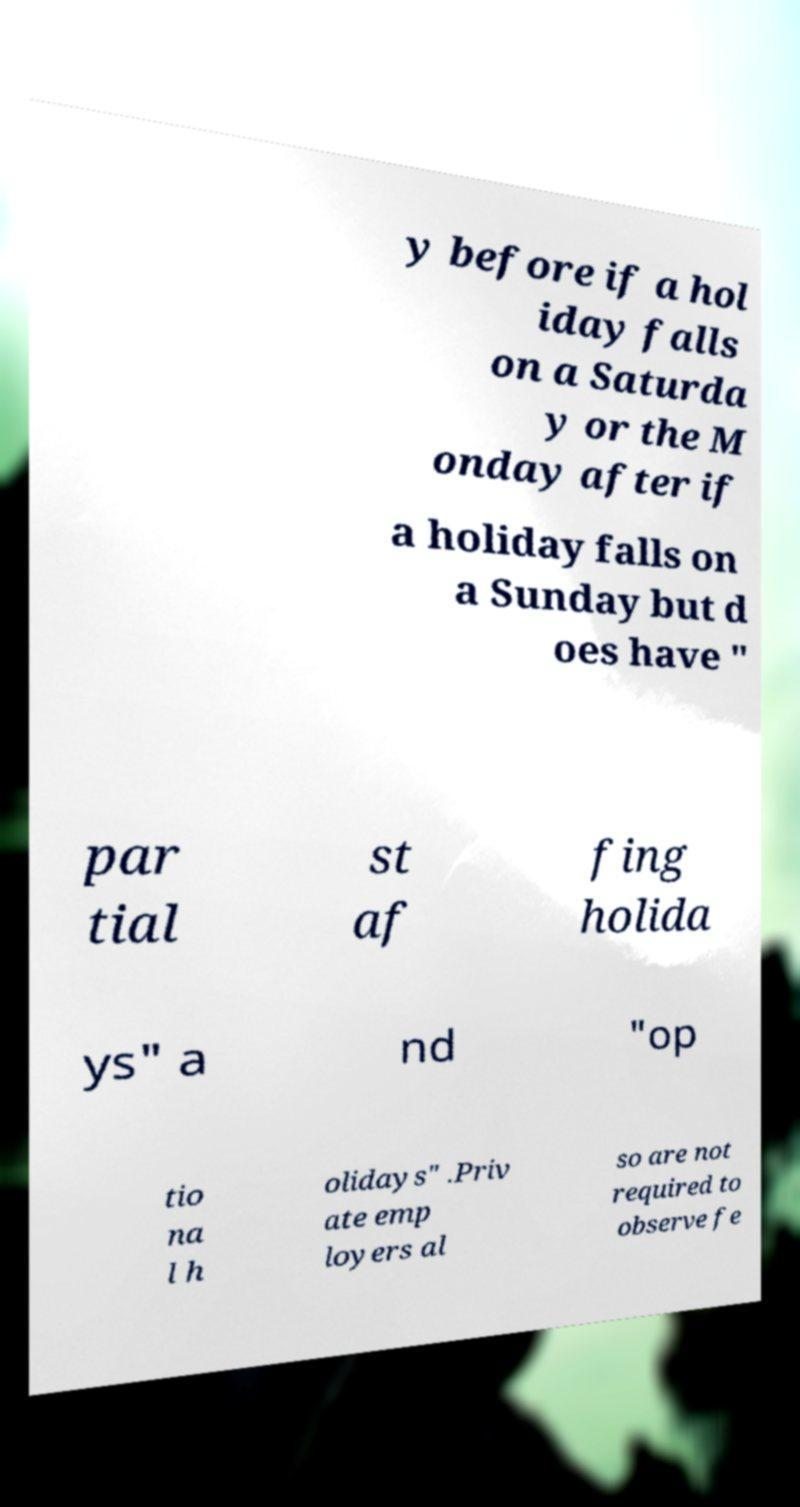Can you read and provide the text displayed in the image?This photo seems to have some interesting text. Can you extract and type it out for me? y before if a hol iday falls on a Saturda y or the M onday after if a holiday falls on a Sunday but d oes have " par tial st af fing holida ys" a nd "op tio na l h olidays" .Priv ate emp loyers al so are not required to observe fe 